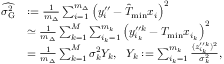Convert formula to latex. <formula><loc_0><loc_0><loc_500><loc_500>\begin{array} { r l } { \widehat { \sigma _ { G } ^ { 2 } } } & { \colon = \frac { 1 } { m _ { \Delta } } \sum _ { i = 1 } ^ { m _ { \Delta } } \left ( y _ { i } ^ { \prime \prime } - \hat { T } _ { \min } x _ { i } \right ) ^ { 2 } } \\ & { \simeq \frac { 1 } { m _ { \Delta } } \sum _ { k = 1 } ^ { M } \sum _ { i _ { k } = 1 } ^ { m _ { k } } \left ( y _ { i _ { k } } ^ { \prime \prime k } - T _ { \min } x _ { i _ { k } } \right ) ^ { 2 } } \\ & { = \frac { 1 } { m _ { \Delta } } \sum _ { k = 1 } ^ { M } \sigma _ { k } ^ { 2 } Y _ { k } , Y _ { k } \colon = \sum _ { i _ { k } = 1 } ^ { m _ { k } } \frac { ( z _ { i _ { k } } ^ { \prime \prime k } ) ^ { 2 } } { \sigma _ { k } ^ { 2 } } , } \end{array}</formula> 